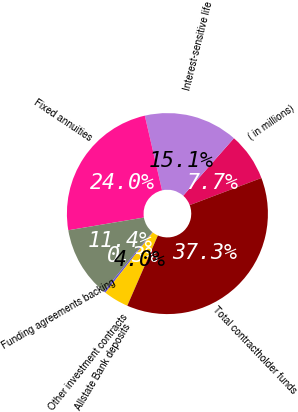Convert chart to OTSL. <chart><loc_0><loc_0><loc_500><loc_500><pie_chart><fcel>( in millions)<fcel>Interest-sensitive life<fcel>Fixed annuities<fcel>Funding agreements backing<fcel>Other investment contracts<fcel>Allstate Bank deposits<fcel>Total contractholder funds<nl><fcel>7.73%<fcel>15.12%<fcel>24.05%<fcel>11.43%<fcel>0.34%<fcel>4.04%<fcel>37.3%<nl></chart> 